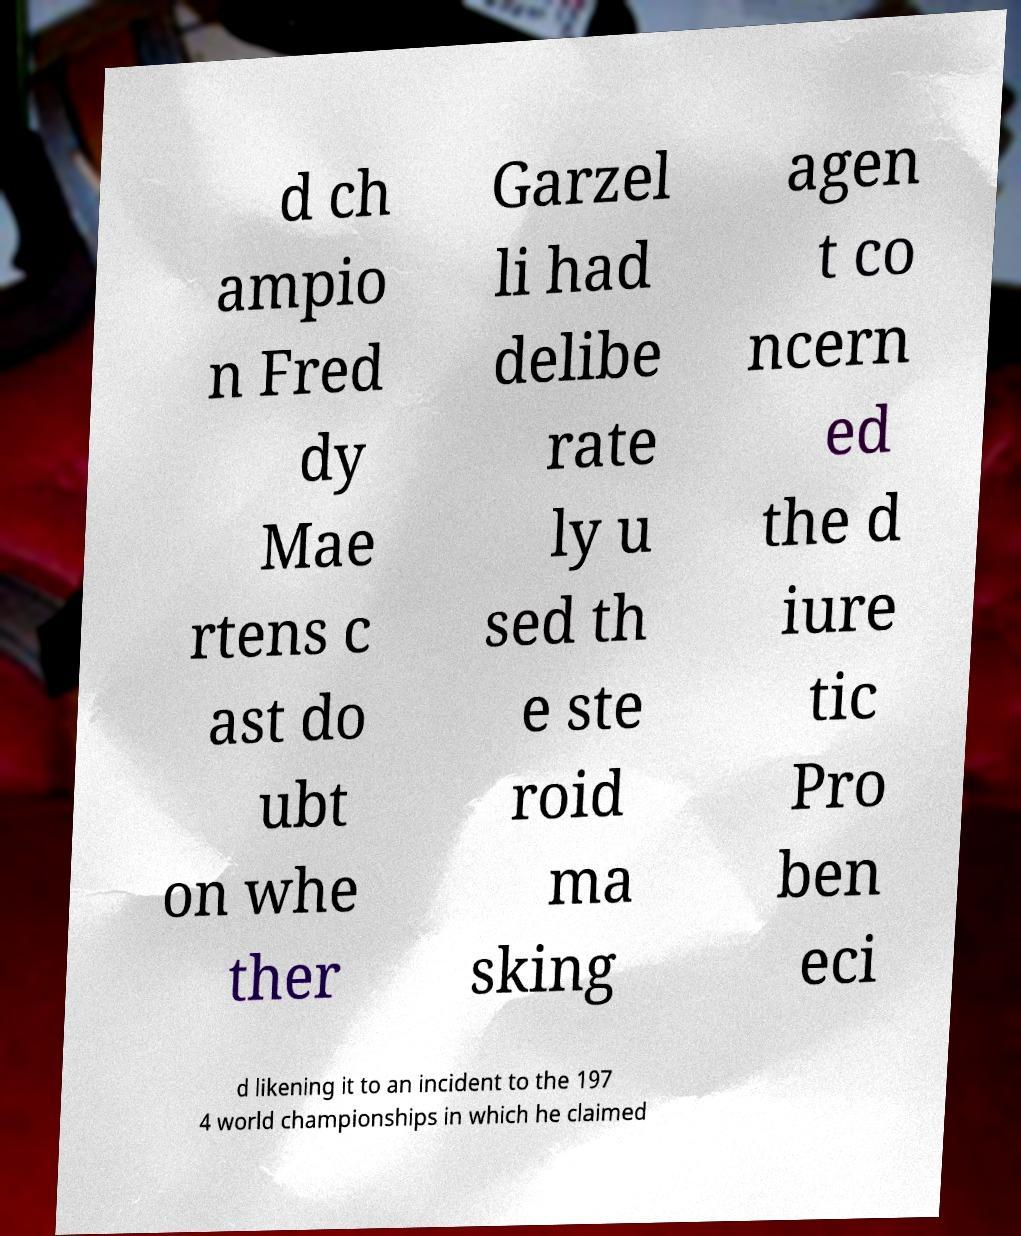There's text embedded in this image that I need extracted. Can you transcribe it verbatim? d ch ampio n Fred dy Mae rtens c ast do ubt on whe ther Garzel li had delibe rate ly u sed th e ste roid ma sking agen t co ncern ed the d iure tic Pro ben eci d likening it to an incident to the 197 4 world championships in which he claimed 